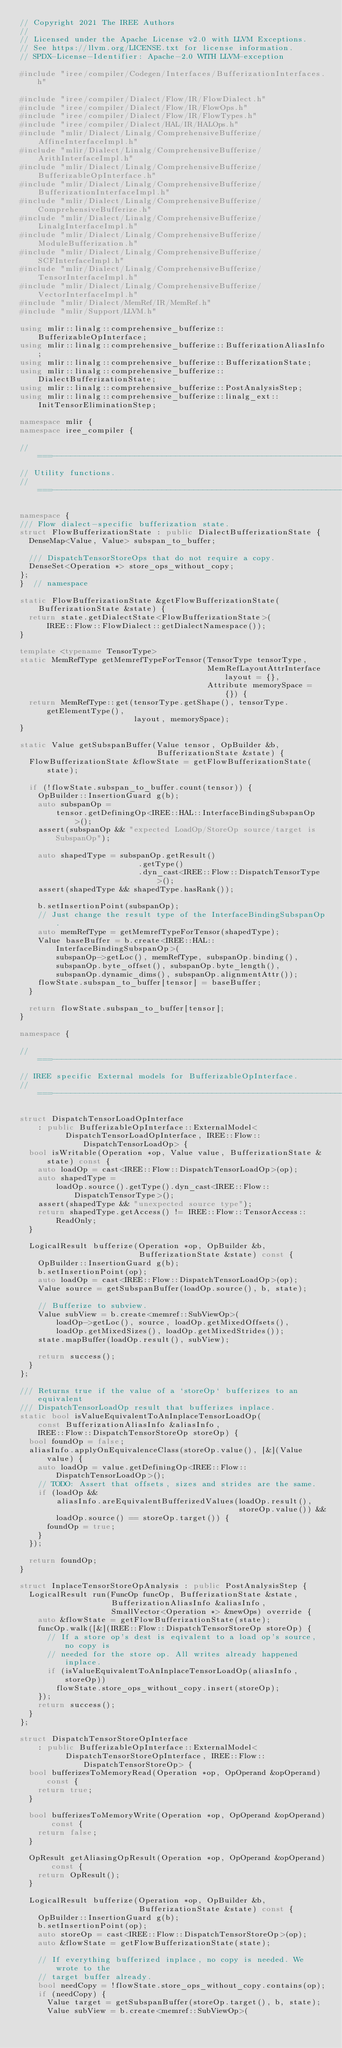<code> <loc_0><loc_0><loc_500><loc_500><_C++_>// Copyright 2021 The IREE Authors
//
// Licensed under the Apache License v2.0 with LLVM Exceptions.
// See https://llvm.org/LICENSE.txt for license information.
// SPDX-License-Identifier: Apache-2.0 WITH LLVM-exception

#include "iree/compiler/Codegen/Interfaces/BufferizationInterfaces.h"

#include "iree/compiler/Dialect/Flow/IR/FlowDialect.h"
#include "iree/compiler/Dialect/Flow/IR/FlowOps.h"
#include "iree/compiler/Dialect/Flow/IR/FlowTypes.h"
#include "iree/compiler/Dialect/HAL/IR/HALOps.h"
#include "mlir/Dialect/Linalg/ComprehensiveBufferize/AffineInterfaceImpl.h"
#include "mlir/Dialect/Linalg/ComprehensiveBufferize/ArithInterfaceImpl.h"
#include "mlir/Dialect/Linalg/ComprehensiveBufferize/BufferizableOpInterface.h"
#include "mlir/Dialect/Linalg/ComprehensiveBufferize/BufferizationInterfaceImpl.h"
#include "mlir/Dialect/Linalg/ComprehensiveBufferize/ComprehensiveBufferize.h"
#include "mlir/Dialect/Linalg/ComprehensiveBufferize/LinalgInterfaceImpl.h"
#include "mlir/Dialect/Linalg/ComprehensiveBufferize/ModuleBufferization.h"
#include "mlir/Dialect/Linalg/ComprehensiveBufferize/SCFInterfaceImpl.h"
#include "mlir/Dialect/Linalg/ComprehensiveBufferize/TensorInterfaceImpl.h"
#include "mlir/Dialect/Linalg/ComprehensiveBufferize/VectorInterfaceImpl.h"
#include "mlir/Dialect/MemRef/IR/MemRef.h"
#include "mlir/Support/LLVM.h"

using mlir::linalg::comprehensive_bufferize::BufferizableOpInterface;
using mlir::linalg::comprehensive_bufferize::BufferizationAliasInfo;
using mlir::linalg::comprehensive_bufferize::BufferizationState;
using mlir::linalg::comprehensive_bufferize::DialectBufferizationState;
using mlir::linalg::comprehensive_bufferize::PostAnalysisStep;
using mlir::linalg::comprehensive_bufferize::linalg_ext::
    InitTensorEliminationStep;

namespace mlir {
namespace iree_compiler {

//===----------------------------------------------------------------------===//
// Utility functions.
//===----------------------------------------------------------------------===//

namespace {
/// Flow dialect-specific bufferization state.
struct FlowBufferizationState : public DialectBufferizationState {
  DenseMap<Value, Value> subspan_to_buffer;

  /// DispatchTensorStoreOps that do not require a copy.
  DenseSet<Operation *> store_ops_without_copy;
};
}  // namespace

static FlowBufferizationState &getFlowBufferizationState(
    BufferizationState &state) {
  return state.getDialectState<FlowBufferizationState>(
      IREE::Flow::FlowDialect::getDialectNamespace());
}

template <typename TensorType>
static MemRefType getMemrefTypeForTensor(TensorType tensorType,
                                         MemRefLayoutAttrInterface layout = {},
                                         Attribute memorySpace = {}) {
  return MemRefType::get(tensorType.getShape(), tensorType.getElementType(),
                         layout, memorySpace);
}

static Value getSubspanBuffer(Value tensor, OpBuilder &b,
                              BufferizationState &state) {
  FlowBufferizationState &flowState = getFlowBufferizationState(state);

  if (!flowState.subspan_to_buffer.count(tensor)) {
    OpBuilder::InsertionGuard g(b);
    auto subspanOp =
        tensor.getDefiningOp<IREE::HAL::InterfaceBindingSubspanOp>();
    assert(subspanOp && "expected LoadOp/StoreOp source/target is SubspanOp");

    auto shapedType = subspanOp.getResult()
                          .getType()
                          .dyn_cast<IREE::Flow::DispatchTensorType>();
    assert(shapedType && shapedType.hasRank());

    b.setInsertionPoint(subspanOp);
    // Just change the result type of the InterfaceBindingSubspanOp.
    auto memRefType = getMemrefTypeForTensor(shapedType);
    Value baseBuffer = b.create<IREE::HAL::InterfaceBindingSubspanOp>(
        subspanOp->getLoc(), memRefType, subspanOp.binding(),
        subspanOp.byte_offset(), subspanOp.byte_length(),
        subspanOp.dynamic_dims(), subspanOp.alignmentAttr());
    flowState.subspan_to_buffer[tensor] = baseBuffer;
  }

  return flowState.subspan_to_buffer[tensor];
}

namespace {

//===----------------------------------------------------------------------===//
// IREE specific External models for BufferizableOpInterface.
//===----------------------------------------------------------------------===//

struct DispatchTensorLoadOpInterface
    : public BufferizableOpInterface::ExternalModel<
          DispatchTensorLoadOpInterface, IREE::Flow::DispatchTensorLoadOp> {
  bool isWritable(Operation *op, Value value, BufferizationState &state) const {
    auto loadOp = cast<IREE::Flow::DispatchTensorLoadOp>(op);
    auto shapedType =
        loadOp.source().getType().dyn_cast<IREE::Flow::DispatchTensorType>();
    assert(shapedType && "unexpected source type");
    return shapedType.getAccess() != IREE::Flow::TensorAccess::ReadOnly;
  }

  LogicalResult bufferize(Operation *op, OpBuilder &b,
                          BufferizationState &state) const {
    OpBuilder::InsertionGuard g(b);
    b.setInsertionPoint(op);
    auto loadOp = cast<IREE::Flow::DispatchTensorLoadOp>(op);
    Value source = getSubspanBuffer(loadOp.source(), b, state);

    // Bufferize to subview.
    Value subView = b.create<memref::SubViewOp>(
        loadOp->getLoc(), source, loadOp.getMixedOffsets(),
        loadOp.getMixedSizes(), loadOp.getMixedStrides());
    state.mapBuffer(loadOp.result(), subView);

    return success();
  }
};

/// Returns true if the value of a `storeOp` bufferizes to an equivalent
/// DispatchTensorLoadOp result that bufferizes inplace.
static bool isValueEquivalentToAnInplaceTensorLoadOp(
    const BufferizationAliasInfo &aliasInfo,
    IREE::Flow::DispatchTensorStoreOp storeOp) {
  bool foundOp = false;
  aliasInfo.applyOnEquivalenceClass(storeOp.value(), [&](Value value) {
    auto loadOp = value.getDefiningOp<IREE::Flow::DispatchTensorLoadOp>();
    // TODO: Assert that offsets, sizes and strides are the same.
    if (loadOp &&
        aliasInfo.areEquivalentBufferizedValues(loadOp.result(),
                                                storeOp.value()) &&
        loadOp.source() == storeOp.target()) {
      foundOp = true;
    }
  });

  return foundOp;
}

struct InplaceTensorStoreOpAnalysis : public PostAnalysisStep {
  LogicalResult run(FuncOp funcOp, BufferizationState &state,
                    BufferizationAliasInfo &aliasInfo,
                    SmallVector<Operation *> &newOps) override {
    auto &flowState = getFlowBufferizationState(state);
    funcOp.walk([&](IREE::Flow::DispatchTensorStoreOp storeOp) {
      // If a store op's dest is eqivalent to a load op's source, no copy is
      // needed for the store op. All writes already happened inplace.
      if (isValueEquivalentToAnInplaceTensorLoadOp(aliasInfo, storeOp))
        flowState.store_ops_without_copy.insert(storeOp);
    });
    return success();
  }
};

struct DispatchTensorStoreOpInterface
    : public BufferizableOpInterface::ExternalModel<
          DispatchTensorStoreOpInterface, IREE::Flow::DispatchTensorStoreOp> {
  bool bufferizesToMemoryRead(Operation *op, OpOperand &opOperand) const {
    return true;
  }

  bool bufferizesToMemoryWrite(Operation *op, OpOperand &opOperand) const {
    return false;
  }

  OpResult getAliasingOpResult(Operation *op, OpOperand &opOperand) const {
    return OpResult();
  }

  LogicalResult bufferize(Operation *op, OpBuilder &b,
                          BufferizationState &state) const {
    OpBuilder::InsertionGuard g(b);
    b.setInsertionPoint(op);
    auto storeOp = cast<IREE::Flow::DispatchTensorStoreOp>(op);
    auto &flowState = getFlowBufferizationState(state);

    // If everything bufferized inplace, no copy is needed. We wrote to the
    // target buffer already.
    bool needCopy = !flowState.store_ops_without_copy.contains(op);
    if (needCopy) {
      Value target = getSubspanBuffer(storeOp.target(), b, state);
      Value subView = b.create<memref::SubViewOp>(</code> 